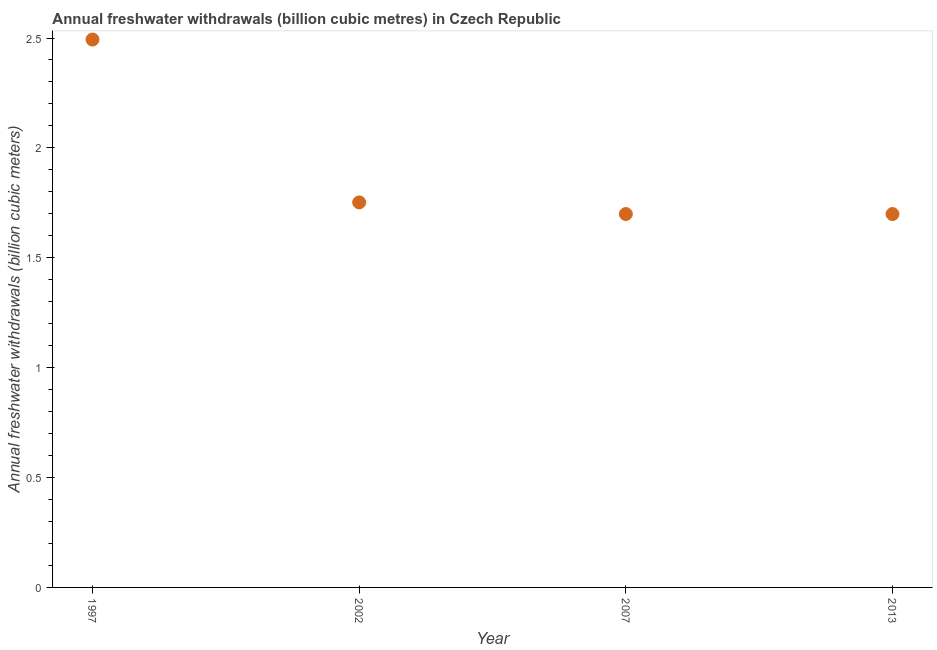What is the annual freshwater withdrawals in 2002?
Provide a succinct answer. 1.75. Across all years, what is the maximum annual freshwater withdrawals?
Your answer should be very brief. 2.49. Across all years, what is the minimum annual freshwater withdrawals?
Your response must be concise. 1.7. In which year was the annual freshwater withdrawals maximum?
Your answer should be very brief. 1997. In which year was the annual freshwater withdrawals minimum?
Your response must be concise. 2007. What is the sum of the annual freshwater withdrawals?
Your response must be concise. 7.64. What is the difference between the annual freshwater withdrawals in 2002 and 2013?
Keep it short and to the point. 0.05. What is the average annual freshwater withdrawals per year?
Keep it short and to the point. 1.91. What is the median annual freshwater withdrawals?
Keep it short and to the point. 1.73. In how many years, is the annual freshwater withdrawals greater than 1.9 billion cubic meters?
Your answer should be very brief. 1. What is the ratio of the annual freshwater withdrawals in 1997 to that in 2007?
Your answer should be very brief. 1.47. Is the annual freshwater withdrawals in 2002 less than that in 2013?
Your response must be concise. No. Is the difference between the annual freshwater withdrawals in 1997 and 2007 greater than the difference between any two years?
Make the answer very short. Yes. What is the difference between the highest and the second highest annual freshwater withdrawals?
Provide a short and direct response. 0.74. Is the sum of the annual freshwater withdrawals in 2002 and 2013 greater than the maximum annual freshwater withdrawals across all years?
Ensure brevity in your answer.  Yes. What is the difference between the highest and the lowest annual freshwater withdrawals?
Offer a very short reply. 0.79. In how many years, is the annual freshwater withdrawals greater than the average annual freshwater withdrawals taken over all years?
Your answer should be compact. 1. What is the title of the graph?
Offer a terse response. Annual freshwater withdrawals (billion cubic metres) in Czech Republic. What is the label or title of the X-axis?
Offer a terse response. Year. What is the label or title of the Y-axis?
Your answer should be very brief. Annual freshwater withdrawals (billion cubic meters). What is the Annual freshwater withdrawals (billion cubic meters) in 1997?
Ensure brevity in your answer.  2.49. What is the Annual freshwater withdrawals (billion cubic meters) in 2002?
Keep it short and to the point. 1.75. What is the Annual freshwater withdrawals (billion cubic meters) in 2007?
Your response must be concise. 1.7. What is the Annual freshwater withdrawals (billion cubic meters) in 2013?
Your response must be concise. 1.7. What is the difference between the Annual freshwater withdrawals (billion cubic meters) in 1997 and 2002?
Ensure brevity in your answer.  0.74. What is the difference between the Annual freshwater withdrawals (billion cubic meters) in 1997 and 2007?
Your answer should be compact. 0.79. What is the difference between the Annual freshwater withdrawals (billion cubic meters) in 1997 and 2013?
Provide a succinct answer. 0.79. What is the difference between the Annual freshwater withdrawals (billion cubic meters) in 2002 and 2007?
Provide a succinct answer. 0.05. What is the difference between the Annual freshwater withdrawals (billion cubic meters) in 2002 and 2013?
Provide a short and direct response. 0.05. What is the difference between the Annual freshwater withdrawals (billion cubic meters) in 2007 and 2013?
Ensure brevity in your answer.  0. What is the ratio of the Annual freshwater withdrawals (billion cubic meters) in 1997 to that in 2002?
Your answer should be compact. 1.42. What is the ratio of the Annual freshwater withdrawals (billion cubic meters) in 1997 to that in 2007?
Your response must be concise. 1.47. What is the ratio of the Annual freshwater withdrawals (billion cubic meters) in 1997 to that in 2013?
Offer a very short reply. 1.47. What is the ratio of the Annual freshwater withdrawals (billion cubic meters) in 2002 to that in 2007?
Your answer should be very brief. 1.03. What is the ratio of the Annual freshwater withdrawals (billion cubic meters) in 2002 to that in 2013?
Give a very brief answer. 1.03. 